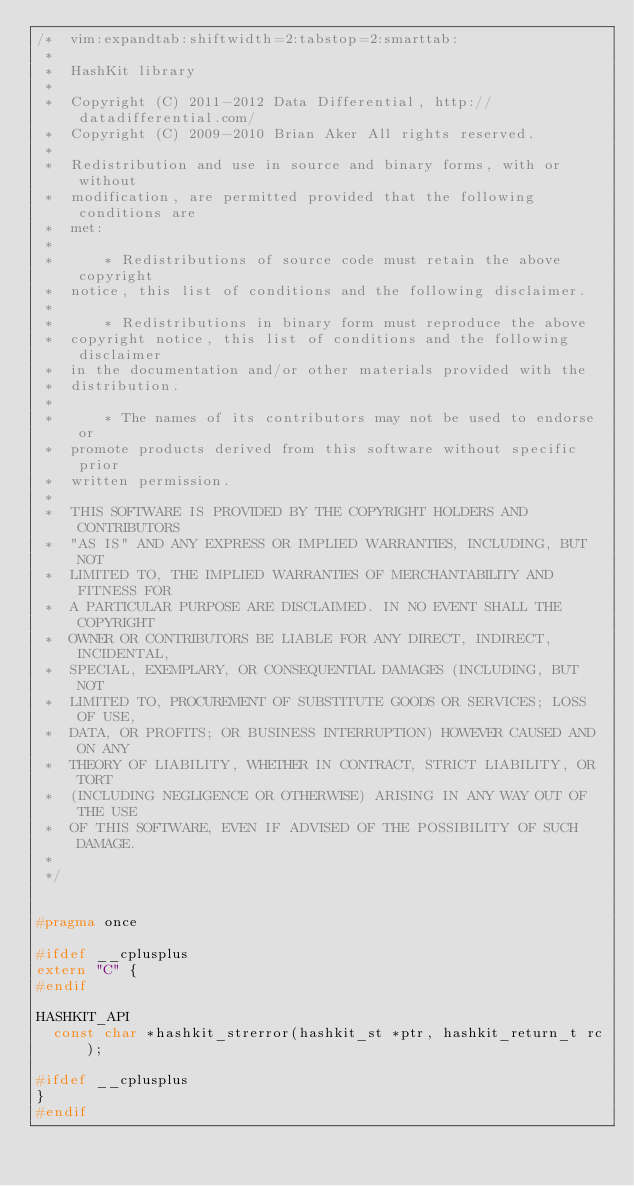<code> <loc_0><loc_0><loc_500><loc_500><_C_>/*  vim:expandtab:shiftwidth=2:tabstop=2:smarttab:
 * 
 *  HashKit library
 *
 *  Copyright (C) 2011-2012 Data Differential, http://datadifferential.com/
 *  Copyright (C) 2009-2010 Brian Aker All rights reserved.
 *
 *  Redistribution and use in source and binary forms, with or without
 *  modification, are permitted provided that the following conditions are
 *  met:
 *
 *      * Redistributions of source code must retain the above copyright
 *  notice, this list of conditions and the following disclaimer.
 *
 *      * Redistributions in binary form must reproduce the above
 *  copyright notice, this list of conditions and the following disclaimer
 *  in the documentation and/or other materials provided with the
 *  distribution.
 *
 *      * The names of its contributors may not be used to endorse or
 *  promote products derived from this software without specific prior
 *  written permission.
 *
 *  THIS SOFTWARE IS PROVIDED BY THE COPYRIGHT HOLDERS AND CONTRIBUTORS
 *  "AS IS" AND ANY EXPRESS OR IMPLIED WARRANTIES, INCLUDING, BUT NOT
 *  LIMITED TO, THE IMPLIED WARRANTIES OF MERCHANTABILITY AND FITNESS FOR
 *  A PARTICULAR PURPOSE ARE DISCLAIMED. IN NO EVENT SHALL THE COPYRIGHT
 *  OWNER OR CONTRIBUTORS BE LIABLE FOR ANY DIRECT, INDIRECT, INCIDENTAL,
 *  SPECIAL, EXEMPLARY, OR CONSEQUENTIAL DAMAGES (INCLUDING, BUT NOT
 *  LIMITED TO, PROCUREMENT OF SUBSTITUTE GOODS OR SERVICES; LOSS OF USE,
 *  DATA, OR PROFITS; OR BUSINESS INTERRUPTION) HOWEVER CAUSED AND ON ANY
 *  THEORY OF LIABILITY, WHETHER IN CONTRACT, STRICT LIABILITY, OR TORT
 *  (INCLUDING NEGLIGENCE OR OTHERWISE) ARISING IN ANY WAY OUT OF THE USE
 *  OF THIS SOFTWARE, EVEN IF ADVISED OF THE POSSIBILITY OF SUCH DAMAGE.
 *
 */


#pragma once

#ifdef __cplusplus
extern "C" {
#endif

HASHKIT_API
  const char *hashkit_strerror(hashkit_st *ptr, hashkit_return_t rc);

#ifdef __cplusplus
}
#endif
</code> 